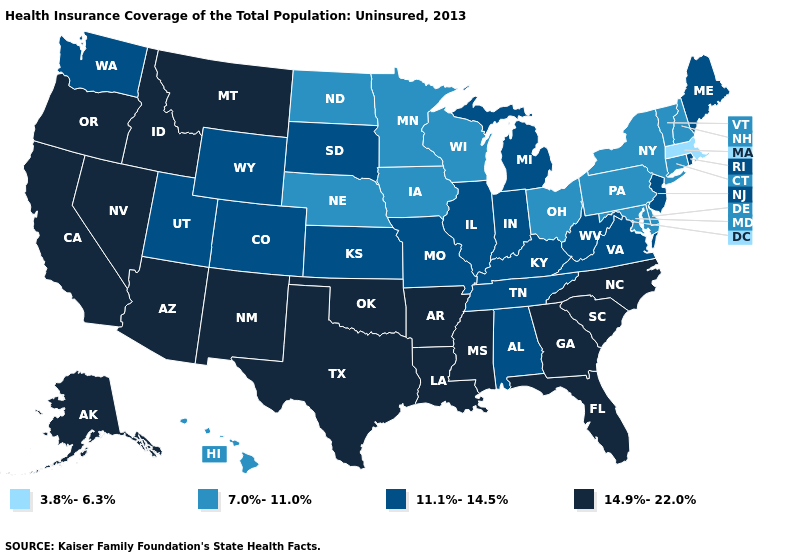Among the states that border Montana , does North Dakota have the lowest value?
Keep it brief. Yes. What is the highest value in the USA?
Keep it brief. 14.9%-22.0%. Which states have the lowest value in the USA?
Keep it brief. Massachusetts. What is the highest value in states that border Alabama?
Short answer required. 14.9%-22.0%. What is the highest value in the MidWest ?
Short answer required. 11.1%-14.5%. What is the highest value in states that border Arkansas?
Short answer required. 14.9%-22.0%. Name the states that have a value in the range 14.9%-22.0%?
Concise answer only. Alaska, Arizona, Arkansas, California, Florida, Georgia, Idaho, Louisiana, Mississippi, Montana, Nevada, New Mexico, North Carolina, Oklahoma, Oregon, South Carolina, Texas. Does the map have missing data?
Concise answer only. No. Name the states that have a value in the range 3.8%-6.3%?
Quick response, please. Massachusetts. Does Massachusetts have the lowest value in the USA?
Answer briefly. Yes. Name the states that have a value in the range 11.1%-14.5%?
Give a very brief answer. Alabama, Colorado, Illinois, Indiana, Kansas, Kentucky, Maine, Michigan, Missouri, New Jersey, Rhode Island, South Dakota, Tennessee, Utah, Virginia, Washington, West Virginia, Wyoming. How many symbols are there in the legend?
Quick response, please. 4. Name the states that have a value in the range 11.1%-14.5%?
Be succinct. Alabama, Colorado, Illinois, Indiana, Kansas, Kentucky, Maine, Michigan, Missouri, New Jersey, Rhode Island, South Dakota, Tennessee, Utah, Virginia, Washington, West Virginia, Wyoming. Name the states that have a value in the range 11.1%-14.5%?
Short answer required. Alabama, Colorado, Illinois, Indiana, Kansas, Kentucky, Maine, Michigan, Missouri, New Jersey, Rhode Island, South Dakota, Tennessee, Utah, Virginia, Washington, West Virginia, Wyoming. Does Georgia have the same value as Mississippi?
Answer briefly. Yes. 